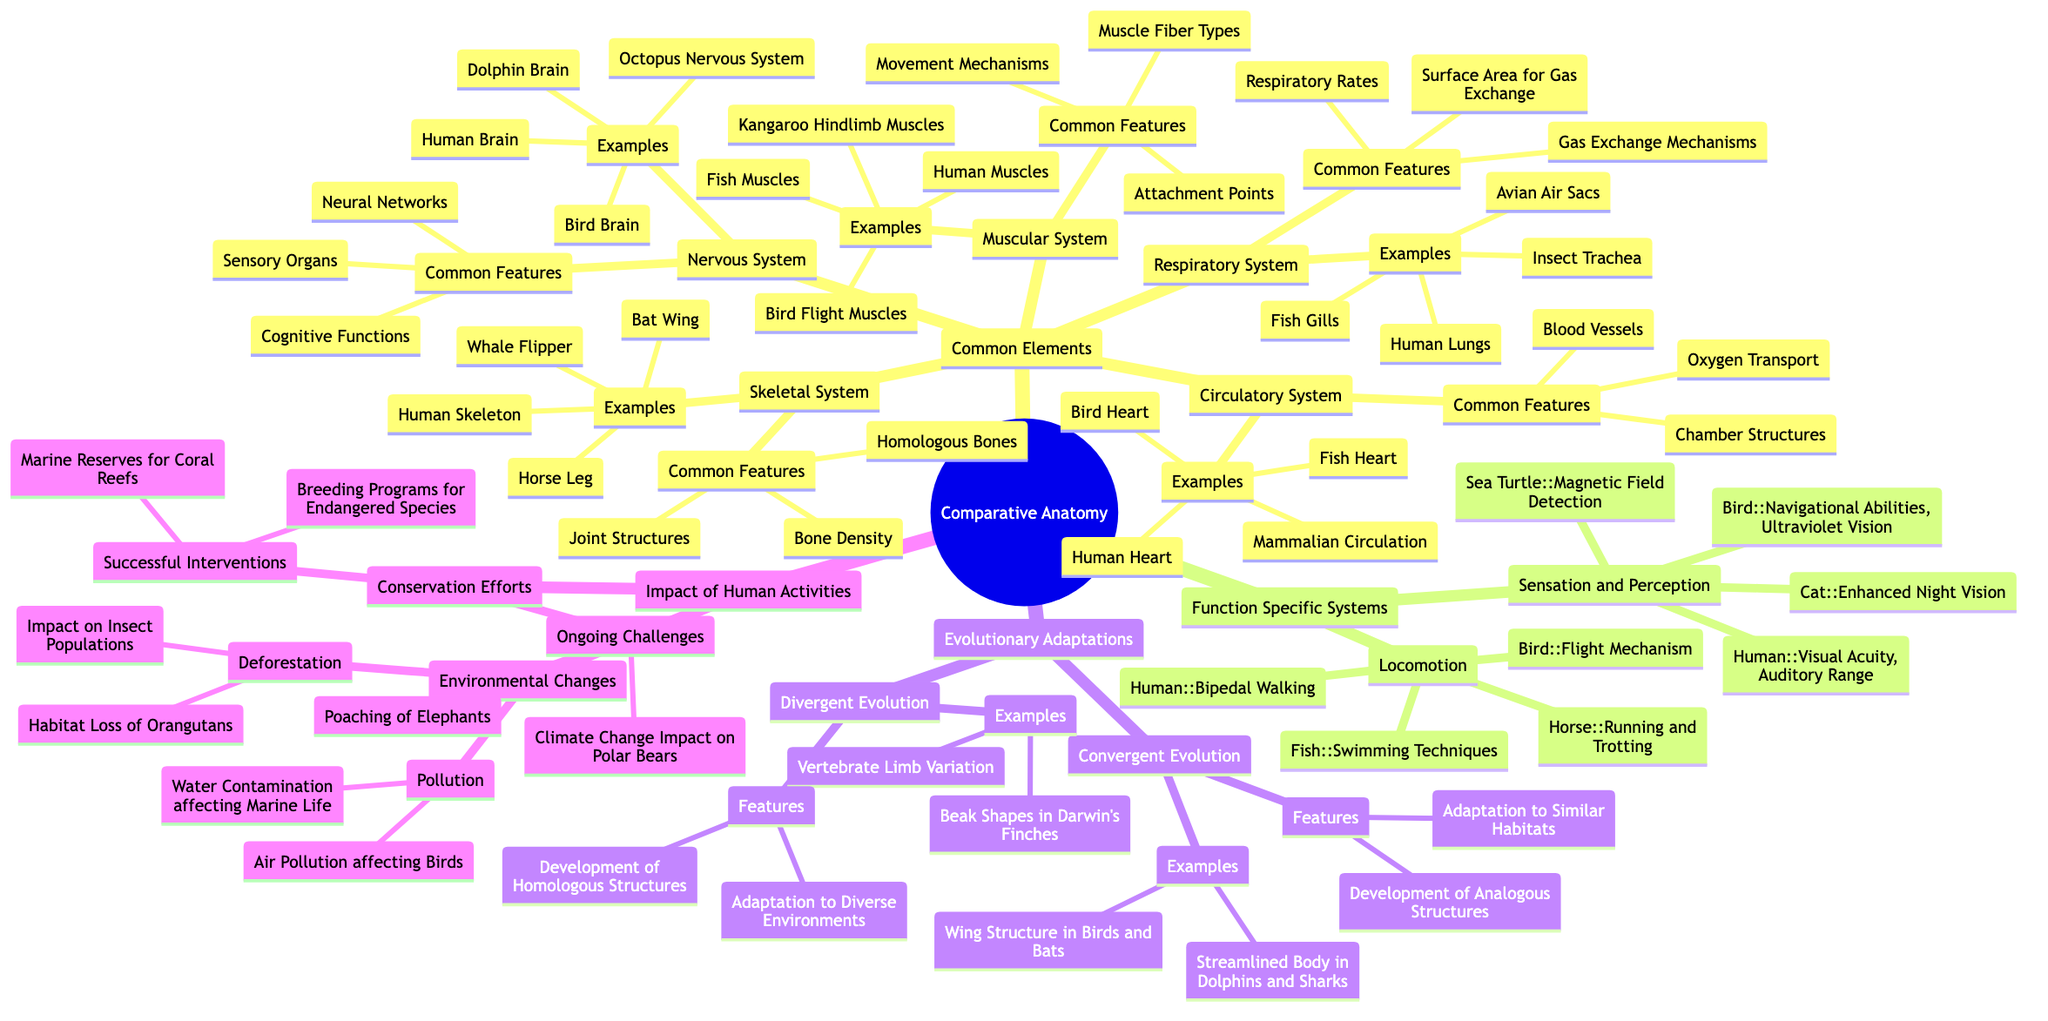What are the examples listed under the Skeletal System? The Skeletal System node provides a list of examples that includes Human Skeleton, Bat Wing, Whale Flipper, and Horse Leg, which are all types of skeletal structures from different species.
Answer: Human Skeleton, Bat Wing, Whale Flipper, Horse Leg What common feature do the examples in the Muscular System share? The Muscular System presents common features such as Muscle Fiber Types, Attachment Points, and Movement Mechanisms, indicating the underlying similarities in muscle function across different species.
Answer: Muscle Fiber Types How many examples are provided under the Nervous System? Under the Nervous System, there are four examples listed: Human Brain, Octopus Nervous System, Bird Brain, and Dolphin Brain, counting them leads to a total of four examples.
Answer: Four Which two systems are specifically mentioned in the Function Specific Systems for locomotion? The Function Specific Systems node under locomotion lists Human with Bipedal Walking, and Bird with Flight Mechanism, indicating the systems and their corresponding locomotion types.
Answer: Human and Bird What is one feature of convergent evolution as mentioned in the diagram? The Convergent Evolution section highlights features such as Adaptation to Similar Habitats, demonstrating how different species can develop similar traits independently due to similar environmental pressures.
Answer: Adaptation to Similar Habitats How are successful interventions in conservation efforts categorized? The Conservation Efforts section categorizes successful interventions into two main types: Breeding Programs for Endangered Species and Marine Reserves for Coral Reefs, reflecting proactive measures for species protection.
Answer: Breeding Programs for Endangered Species Which example is linked to the sensory abilities of birds? The Sensation and Perception section notes that birds possess abilities like Navigational Abilities and Ultraviolet Vision, indicating their acute senses.
Answer: Ultraviolet Vision What is one ongoing challenge listed regarding conservation efforts? Ongoing challenges under the Conservation Efforts node include issues like Poaching of Elephants, indicating the persistent threats some species face despite conservation efforts.
Answer: Poaching of Elephants 